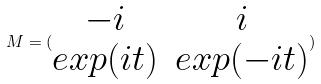Convert formula to latex. <formula><loc_0><loc_0><loc_500><loc_500>M = ( \begin{matrix} - i & i \\ e x p ( i t ) & e x p ( - i t ) \end{matrix} )</formula> 